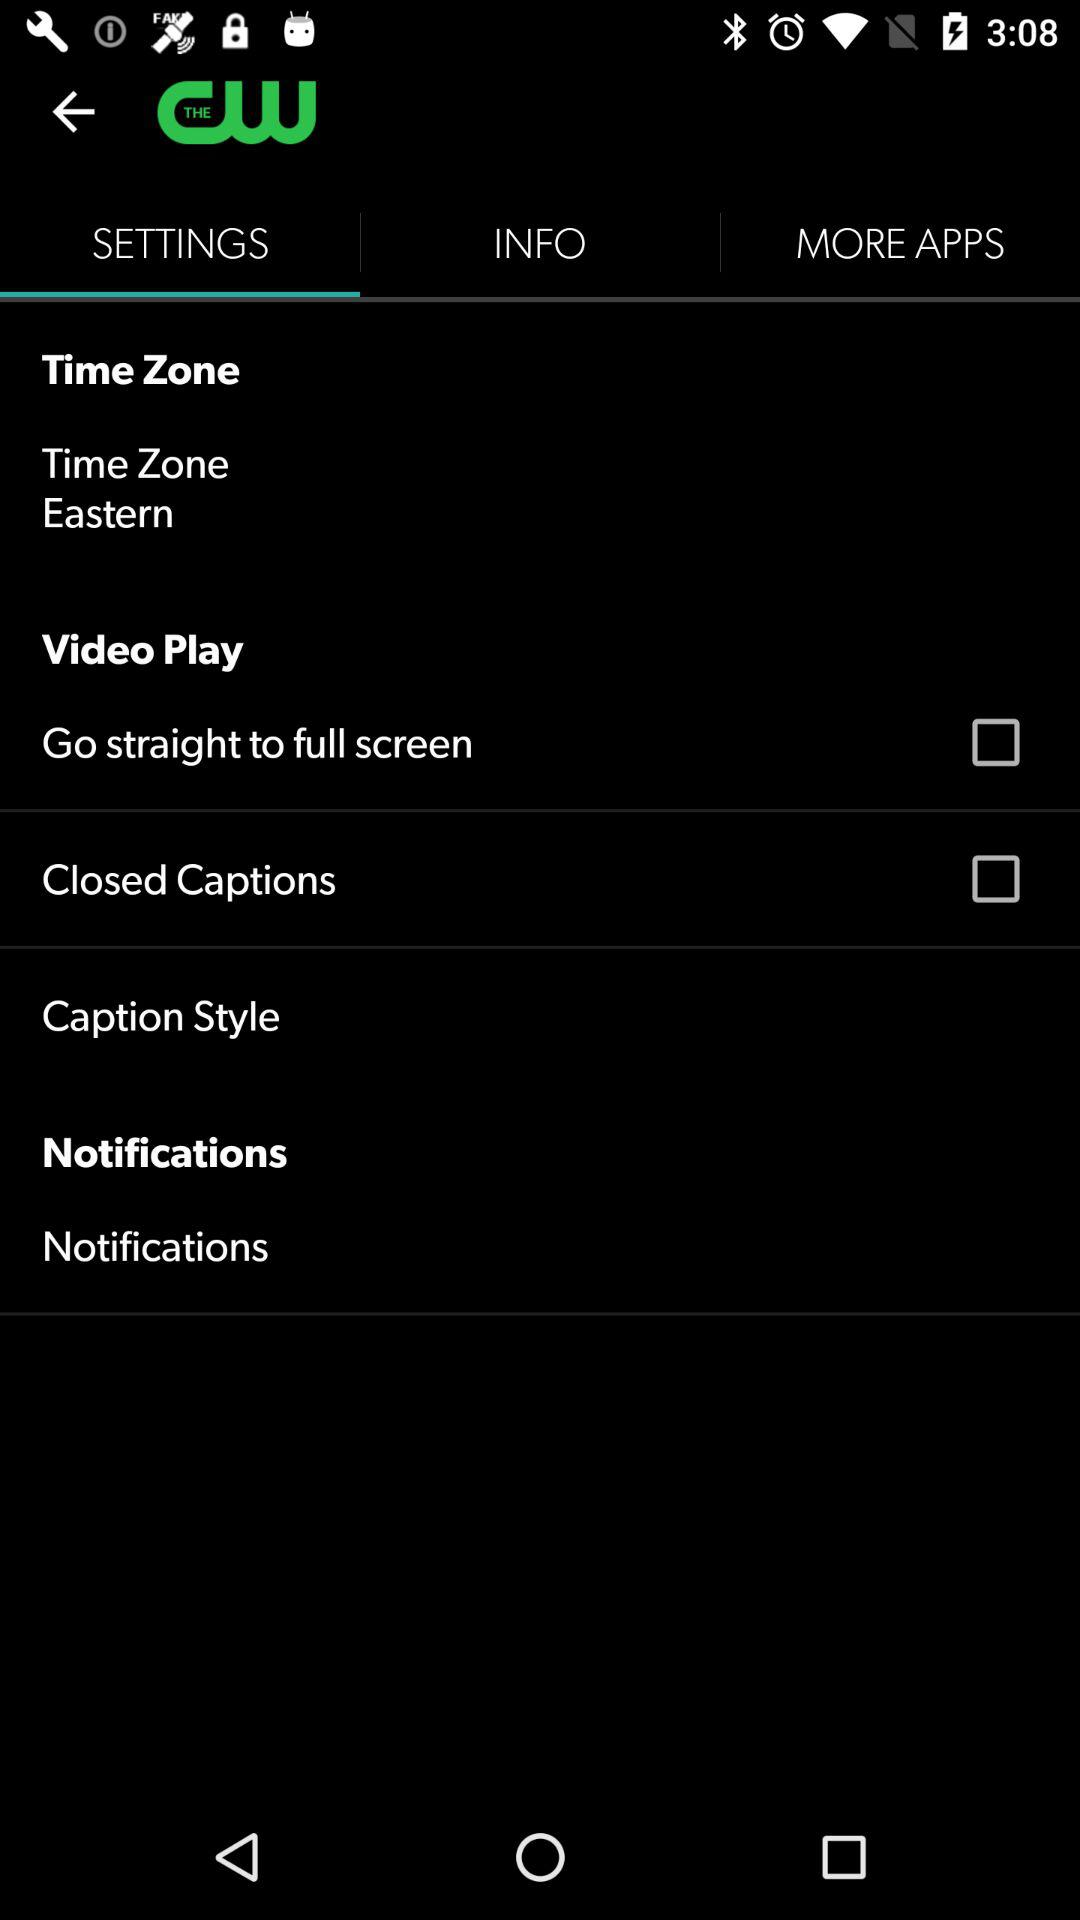Which tab is selected? The selected tab is "SETTINGS". 